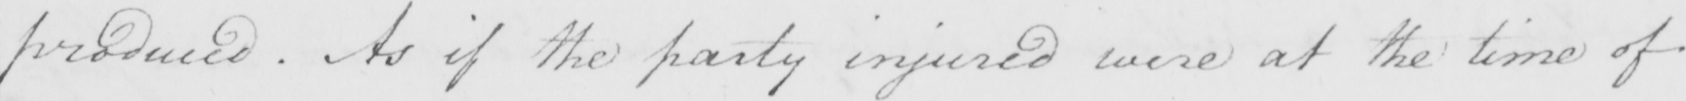What is written in this line of handwriting? produced . As if the party injured were at the time of 